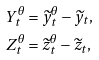<formula> <loc_0><loc_0><loc_500><loc_500>Y _ { t } ^ { \theta } & = \widetilde { y } _ { t } ^ { \theta } - \widetilde { y } _ { t } , \\ Z _ { t } ^ { \theta } & = \widetilde { z } _ { t } ^ { \theta } - \widetilde { z } _ { t } ,</formula> 